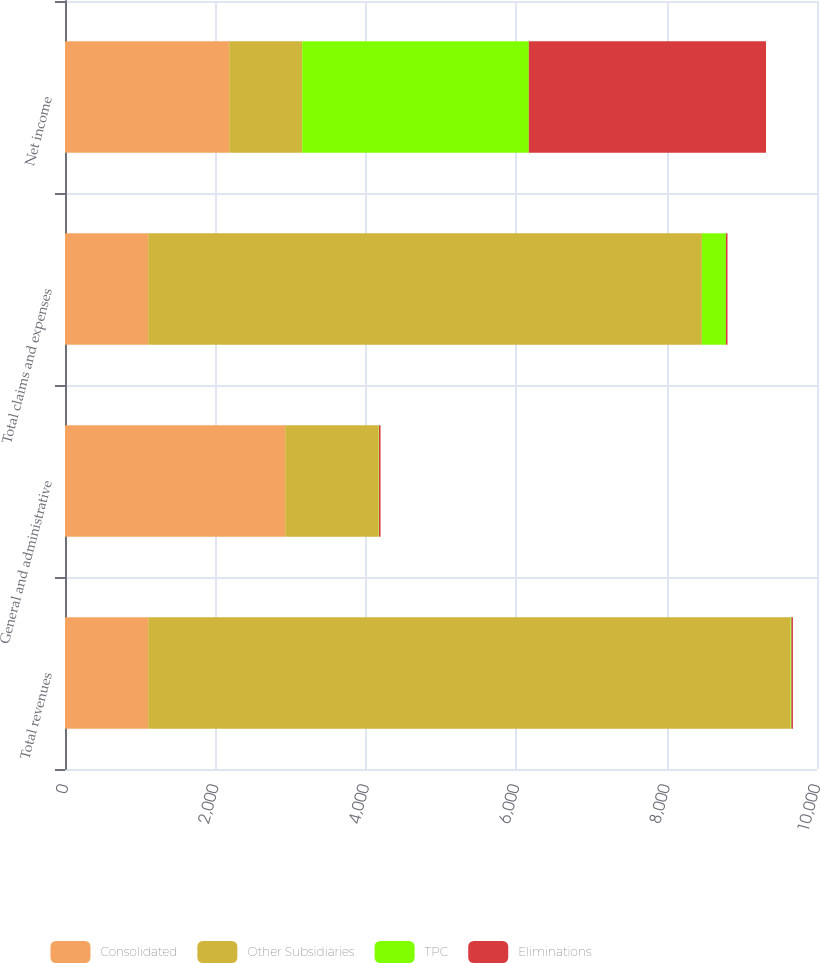Convert chart to OTSL. <chart><loc_0><loc_0><loc_500><loc_500><stacked_bar_chart><ecel><fcel>Total revenues<fcel>General and administrative<fcel>Total claims and expenses<fcel>Net income<nl><fcel>Consolidated<fcel>1106<fcel>2928<fcel>1106<fcel>2184<nl><fcel>Other Subsidiaries<fcel>8541<fcel>1242<fcel>7363<fcel>970<nl><fcel>TPC<fcel>12<fcel>5<fcel>320<fcel>3014<nl><fcel>Eliminations<fcel>21<fcel>21<fcel>21<fcel>3154<nl></chart> 